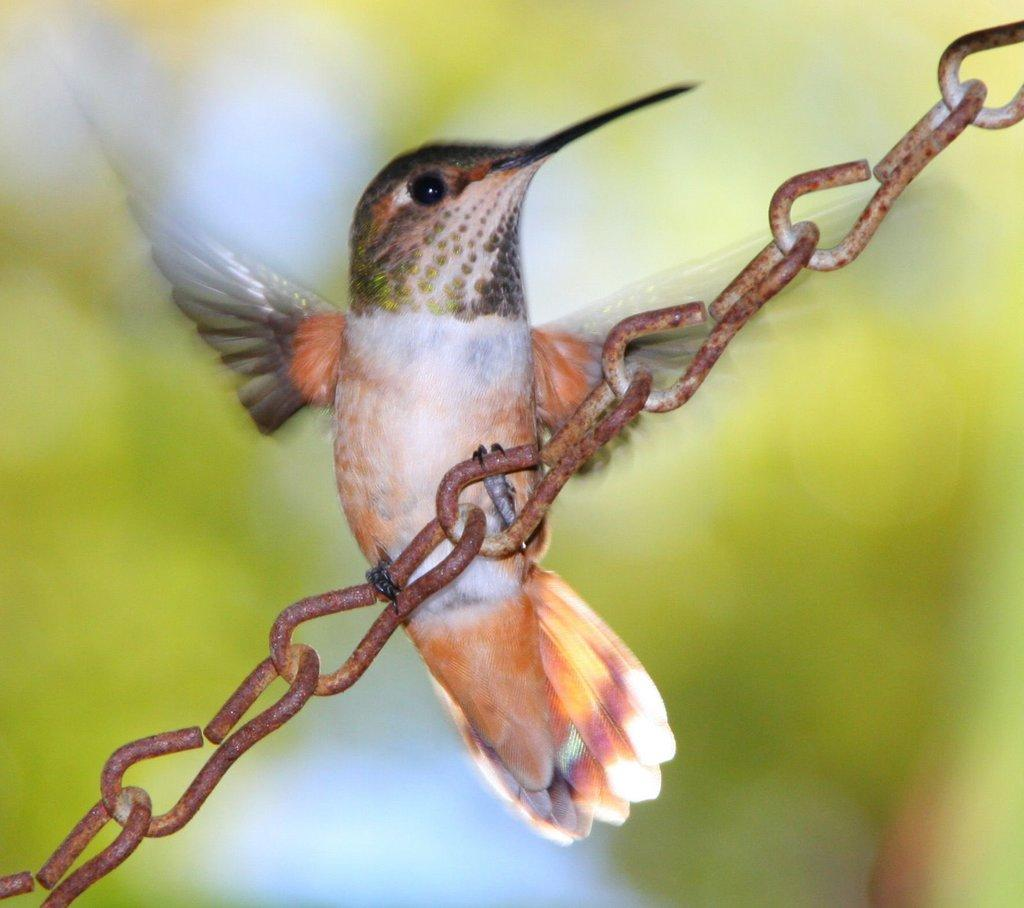What type of animal is in the image? There is a bird in the image. How is the bird positioned in the image? The bird is on a chain. Can you describe the background of the image? The background of the image is blurry. What type of zinc is the bird holding in the image? There is no zinc present in the image; the bird is on a chain. Can you see a zebra in the background of the image? There is no zebra present in the image; the background is blurry. 